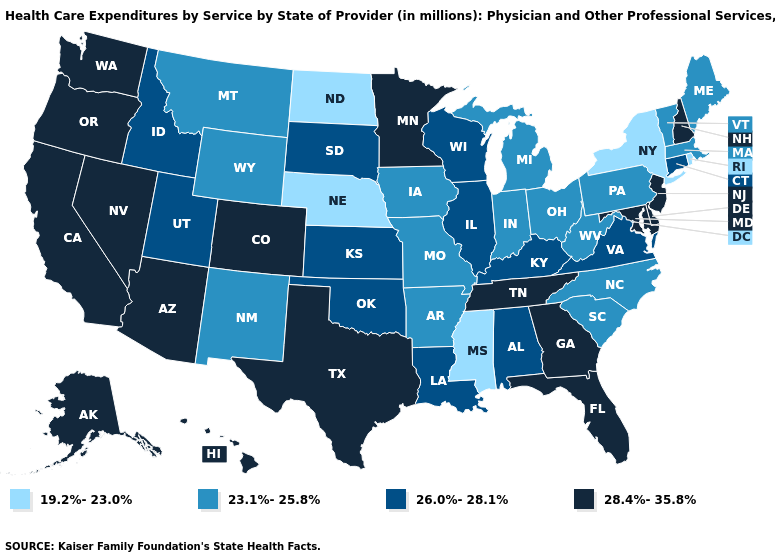Does Nebraska have the same value as Mississippi?
Answer briefly. Yes. Does Florida have a higher value than Wisconsin?
Keep it brief. Yes. What is the value of Wyoming?
Concise answer only. 23.1%-25.8%. Is the legend a continuous bar?
Keep it brief. No. What is the value of North Carolina?
Concise answer only. 23.1%-25.8%. What is the lowest value in the USA?
Answer briefly. 19.2%-23.0%. Does Connecticut have the highest value in the USA?
Concise answer only. No. Name the states that have a value in the range 28.4%-35.8%?
Give a very brief answer. Alaska, Arizona, California, Colorado, Delaware, Florida, Georgia, Hawaii, Maryland, Minnesota, Nevada, New Hampshire, New Jersey, Oregon, Tennessee, Texas, Washington. What is the value of Utah?
Keep it brief. 26.0%-28.1%. Name the states that have a value in the range 19.2%-23.0%?
Concise answer only. Mississippi, Nebraska, New York, North Dakota, Rhode Island. Does the map have missing data?
Give a very brief answer. No. Does Illinois have a lower value than Hawaii?
Short answer required. Yes. Name the states that have a value in the range 19.2%-23.0%?
Quick response, please. Mississippi, Nebraska, New York, North Dakota, Rhode Island. Name the states that have a value in the range 28.4%-35.8%?
Short answer required. Alaska, Arizona, California, Colorado, Delaware, Florida, Georgia, Hawaii, Maryland, Minnesota, Nevada, New Hampshire, New Jersey, Oregon, Tennessee, Texas, Washington. Does Kentucky have the lowest value in the USA?
Keep it brief. No. 